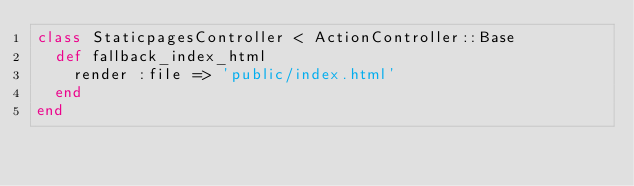<code> <loc_0><loc_0><loc_500><loc_500><_Ruby_>class StaticpagesController < ActionController::Base
  def fallback_index_html
    render :file => 'public/index.html'
  end
end
</code> 